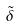<formula> <loc_0><loc_0><loc_500><loc_500>\tilde { \delta }</formula> 